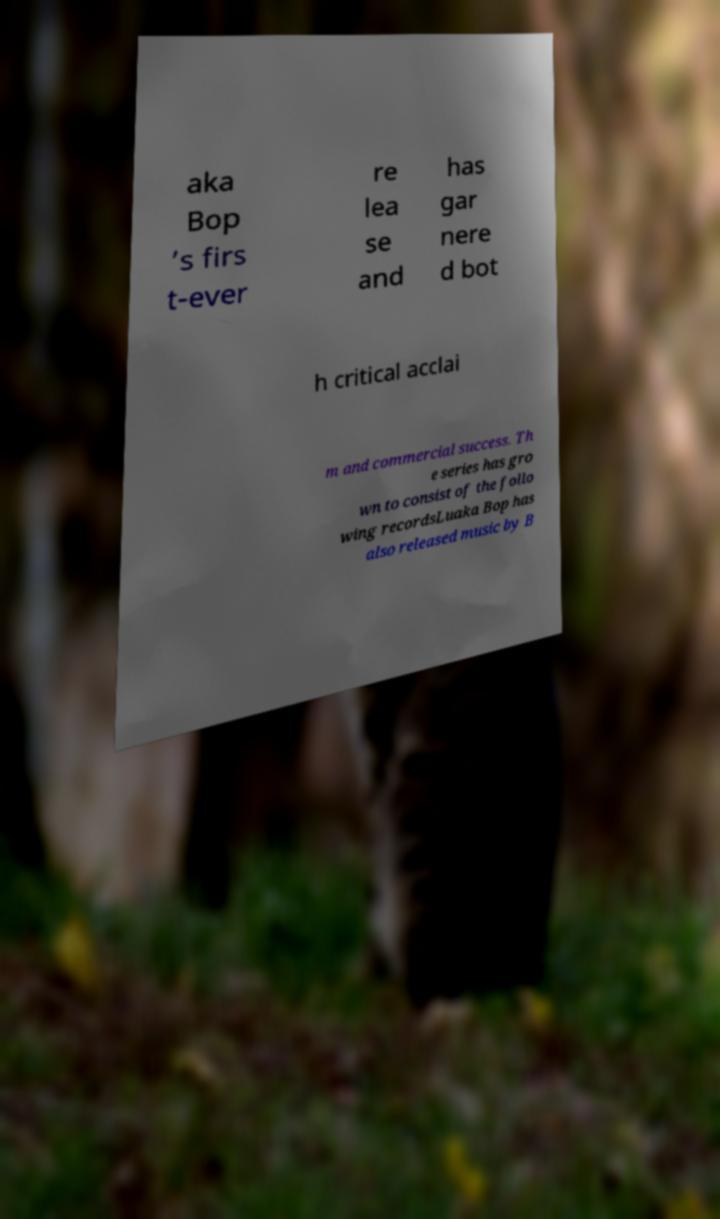Please read and relay the text visible in this image. What does it say? aka Bop ’s firs t-ever re lea se and has gar nere d bot h critical acclai m and commercial success. Th e series has gro wn to consist of the follo wing recordsLuaka Bop has also released music by B 